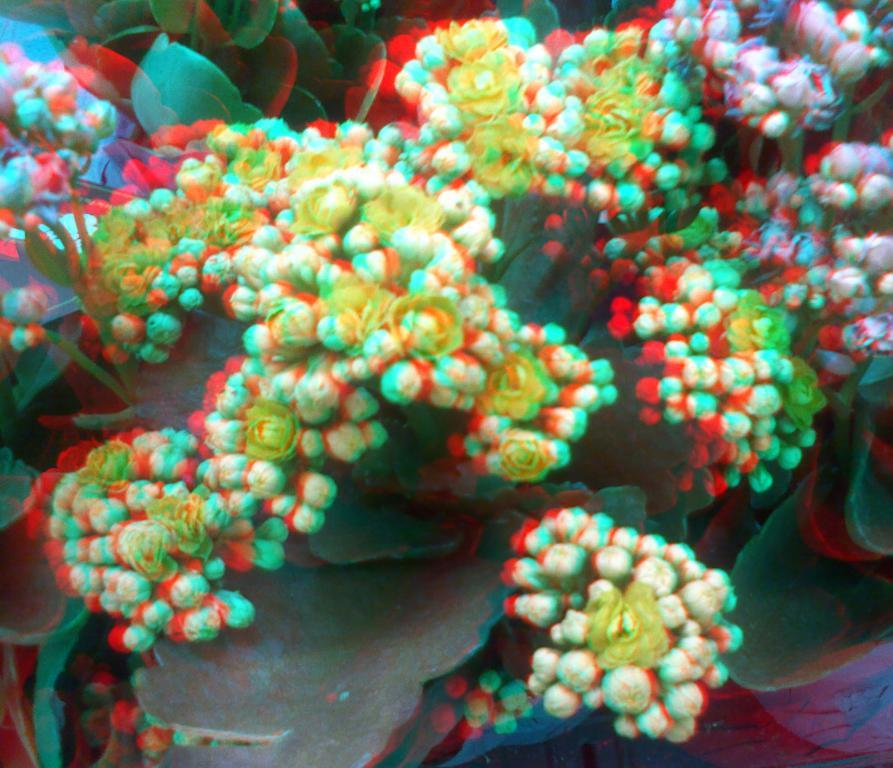What type of living organisms can be seen in the image? Plants and flowers can be seen in the image. What color are the flowers in the image? The flowers in the image are white in color. What type of lettuce is being used to surprise the flowers in the image? There is no lettuce or surprise present in the image; it features plants and white flowers. 